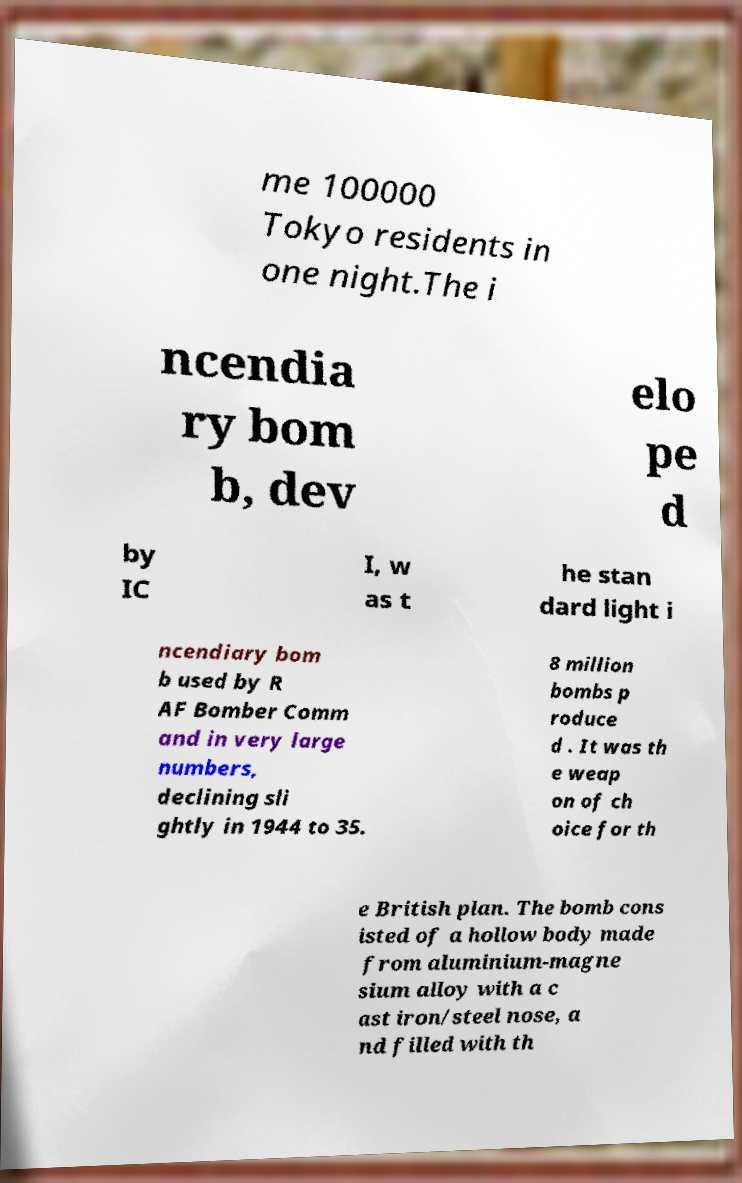I need the written content from this picture converted into text. Can you do that? me 100000 Tokyo residents in one night.The i ncendia ry bom b, dev elo pe d by IC I, w as t he stan dard light i ncendiary bom b used by R AF Bomber Comm and in very large numbers, declining sli ghtly in 1944 to 35. 8 million bombs p roduce d . It was th e weap on of ch oice for th e British plan. The bomb cons isted of a hollow body made from aluminium-magne sium alloy with a c ast iron/steel nose, a nd filled with th 